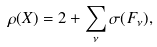<formula> <loc_0><loc_0><loc_500><loc_500>\rho ( X ) = 2 + \sum _ { \nu } \sigma ( F _ { \nu } ) ,</formula> 